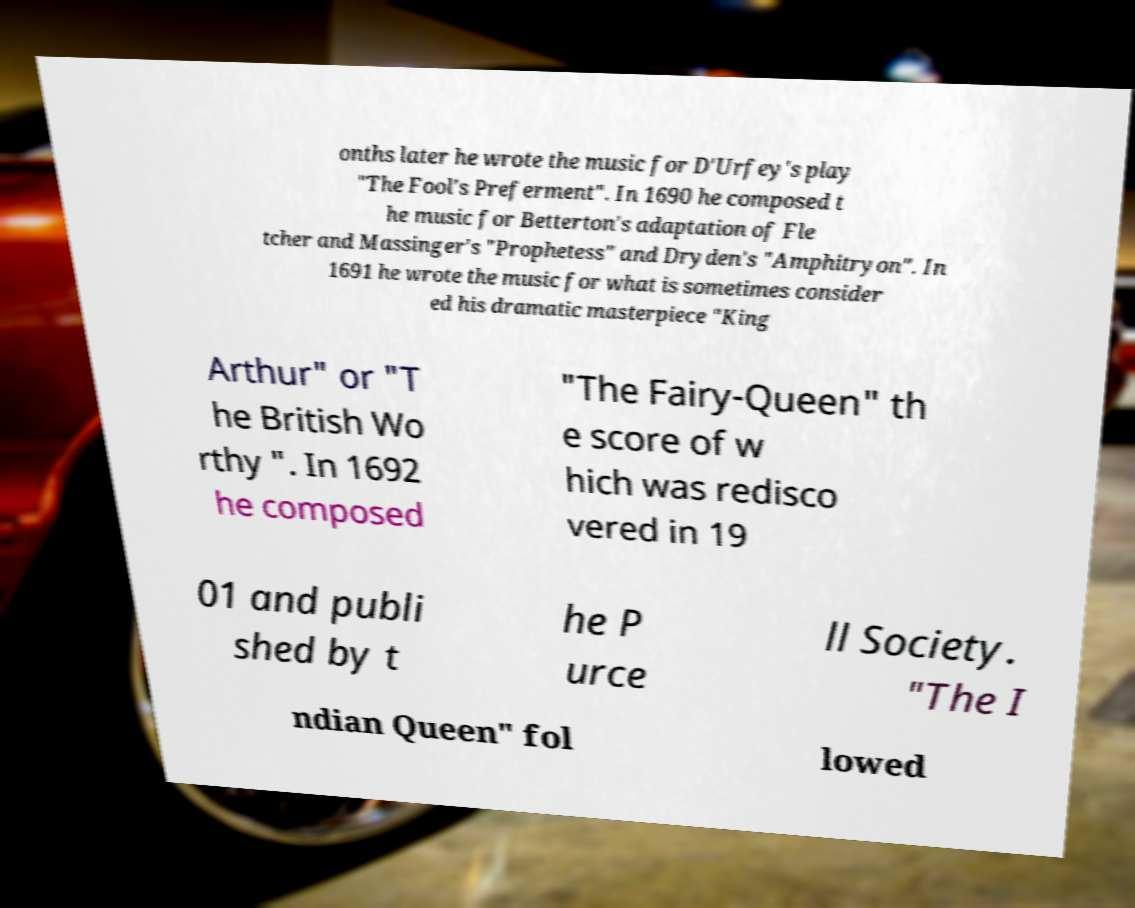Could you assist in decoding the text presented in this image and type it out clearly? onths later he wrote the music for D'Urfey's play "The Fool's Preferment". In 1690 he composed t he music for Betterton's adaptation of Fle tcher and Massinger's "Prophetess" and Dryden's "Amphitryon". In 1691 he wrote the music for what is sometimes consider ed his dramatic masterpiece "King Arthur" or "T he British Wo rthy ". In 1692 he composed "The Fairy-Queen" th e score of w hich was redisco vered in 19 01 and publi shed by t he P urce ll Society. "The I ndian Queen" fol lowed 